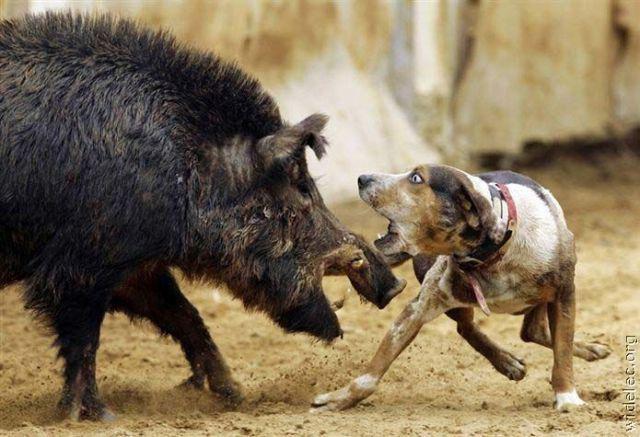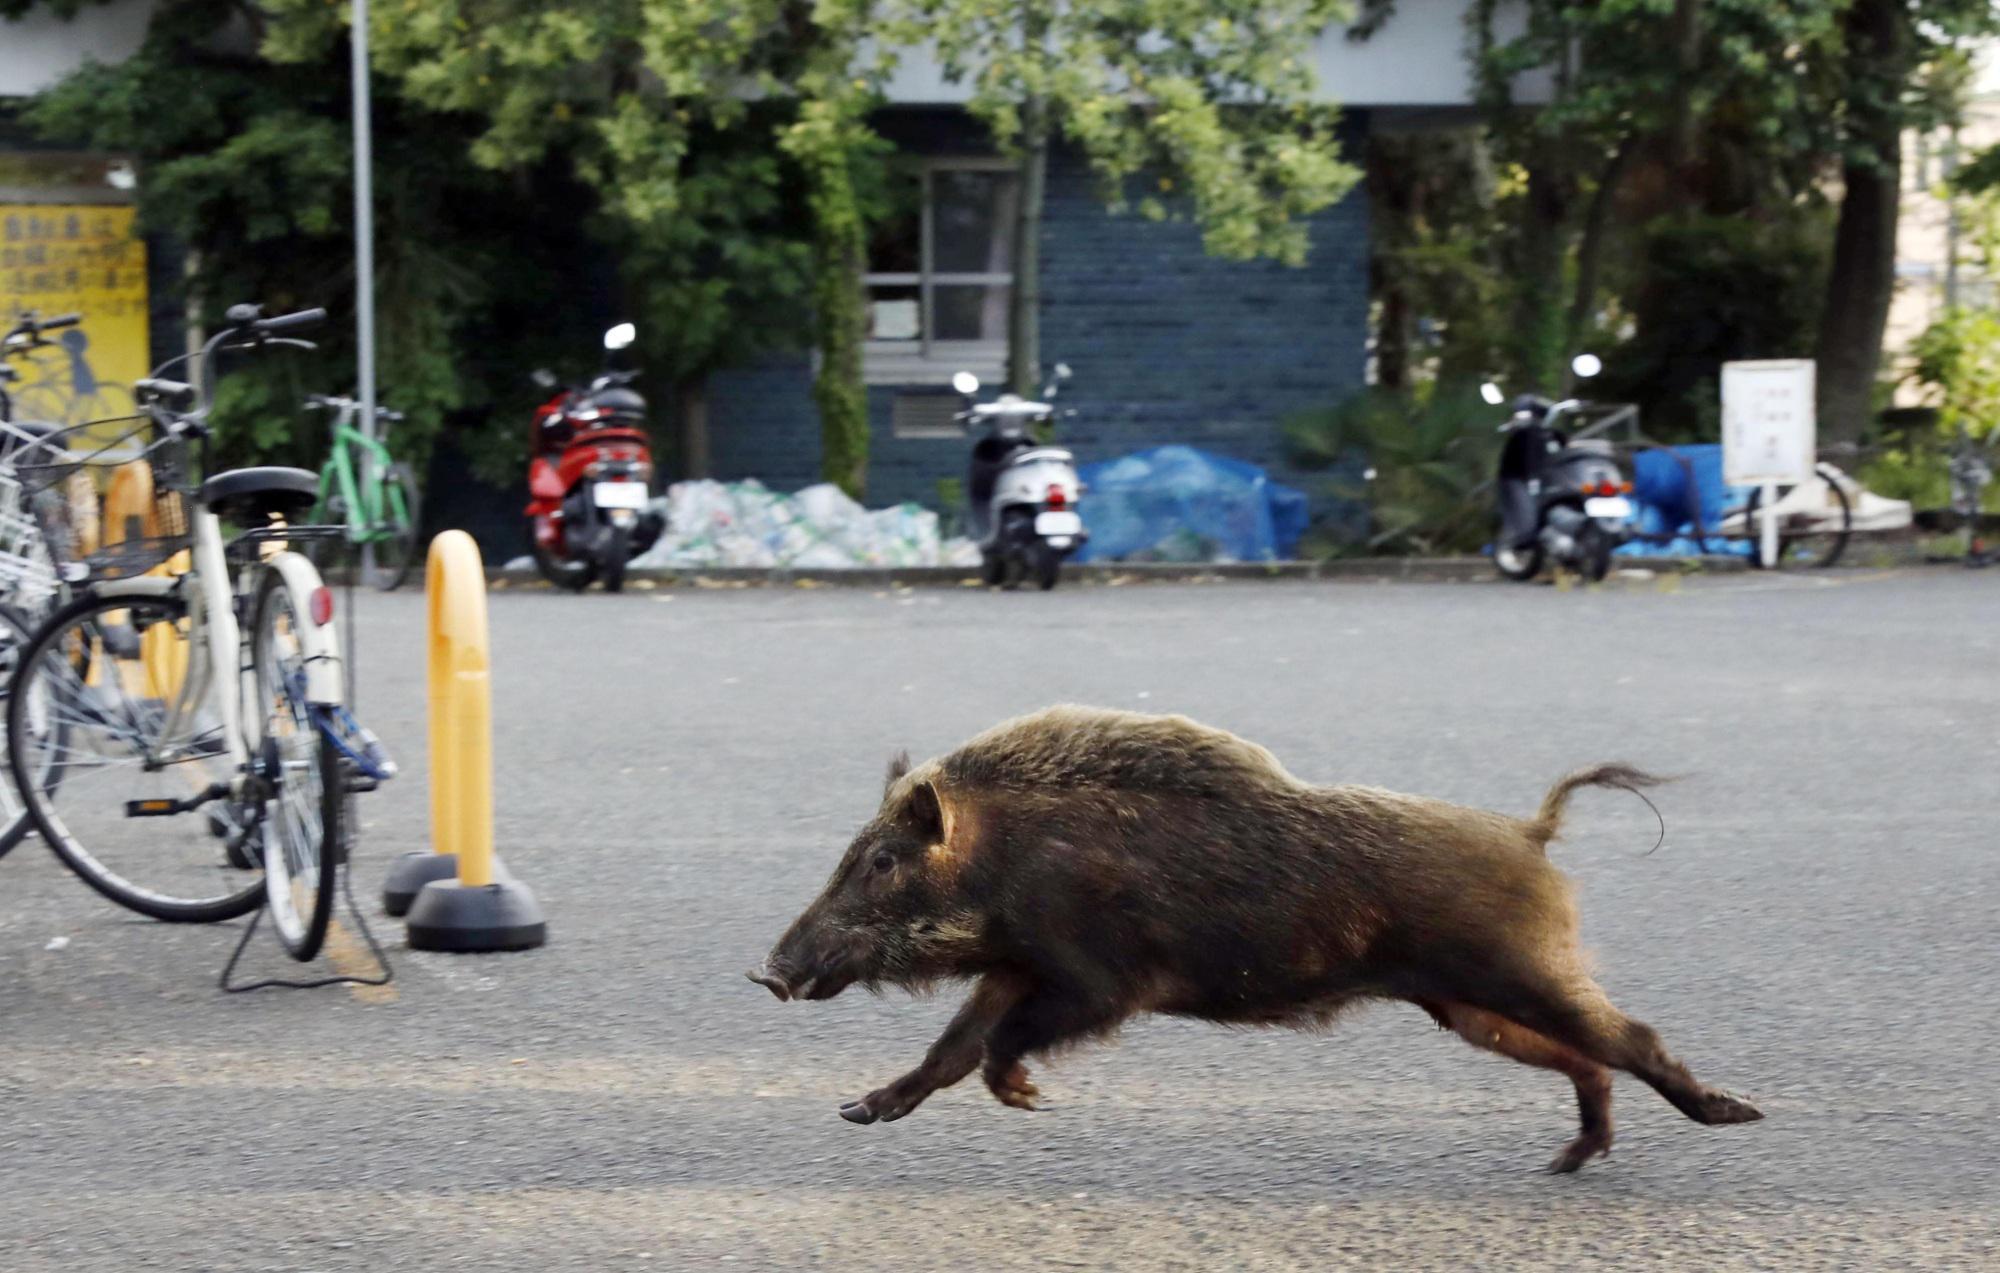The first image is the image on the left, the second image is the image on the right. Evaluate the accuracy of this statement regarding the images: "An image shows a striped baby wild pig standing parallel to a dog with its mouth open wide.". Is it true? Answer yes or no. No. The first image is the image on the left, the second image is the image on the right. Evaluate the accuracy of this statement regarding the images: "One pig is moving across the pavement.". Is it true? Answer yes or no. Yes. 